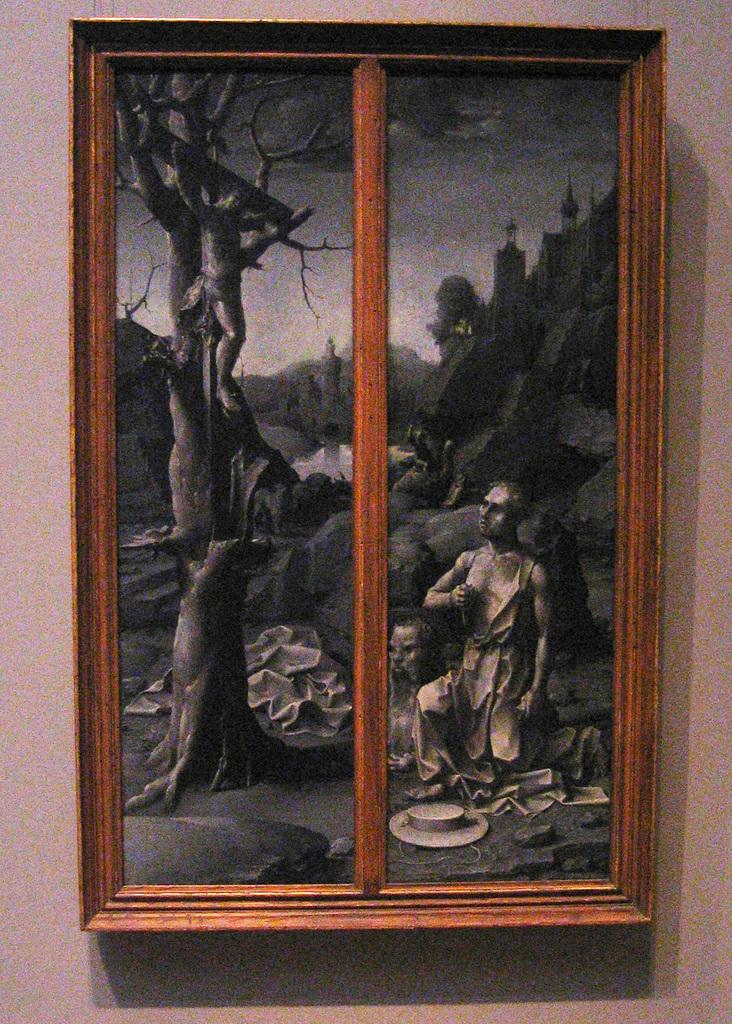What is hanging on the wall in the image? There is a photo frame on the wall. What is the material of the photo frame? The photo frame has a wooden frame. What is depicted inside the photo frame? The photo frame contains an image of a person. What type of natural element can be seen in the image? There is a dry tree in the image. What geological feature is present in the image? There are rocks in the image. What type of alarm is going off in the image? There is no alarm present in the image. What kind of agreement is being signed in the image? There is no agreement or signing activity depicted in the image. 